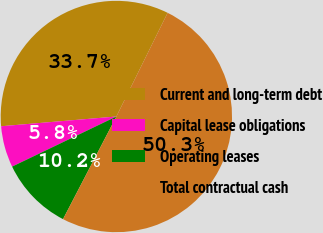<chart> <loc_0><loc_0><loc_500><loc_500><pie_chart><fcel>Current and long-term debt<fcel>Capital lease obligations<fcel>Operating leases<fcel>Total contractual cash<nl><fcel>33.65%<fcel>5.79%<fcel>10.24%<fcel>50.32%<nl></chart> 